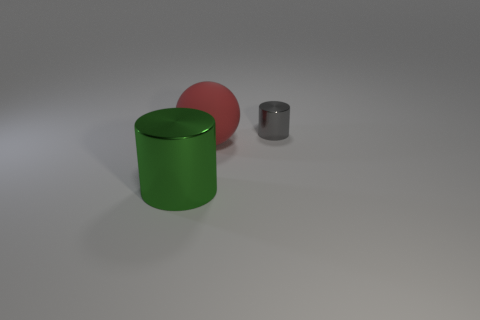Can you describe the lighting in the scene? There is a diffuse and soft lighting in the scene. The shadows are faint and not very sharp, suggesting an ambient light source possibly out of frame. 